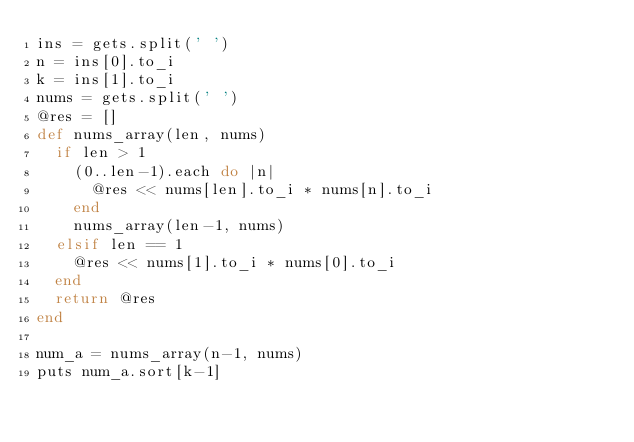Convert code to text. <code><loc_0><loc_0><loc_500><loc_500><_Ruby_>ins = gets.split(' ')
n = ins[0].to_i
k = ins[1].to_i
nums = gets.split(' ')
@res = []
def nums_array(len, nums)
  if len > 1
    (0..len-1).each do |n|
      @res << nums[len].to_i * nums[n].to_i
    end
    nums_array(len-1, nums)
  elsif len == 1
    @res << nums[1].to_i * nums[0].to_i
  end
  return @res
end

num_a = nums_array(n-1, nums)
puts num_a.sort[k-1]</code> 